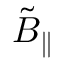Convert formula to latex. <formula><loc_0><loc_0><loc_500><loc_500>\tilde { B } _ { \| }</formula> 